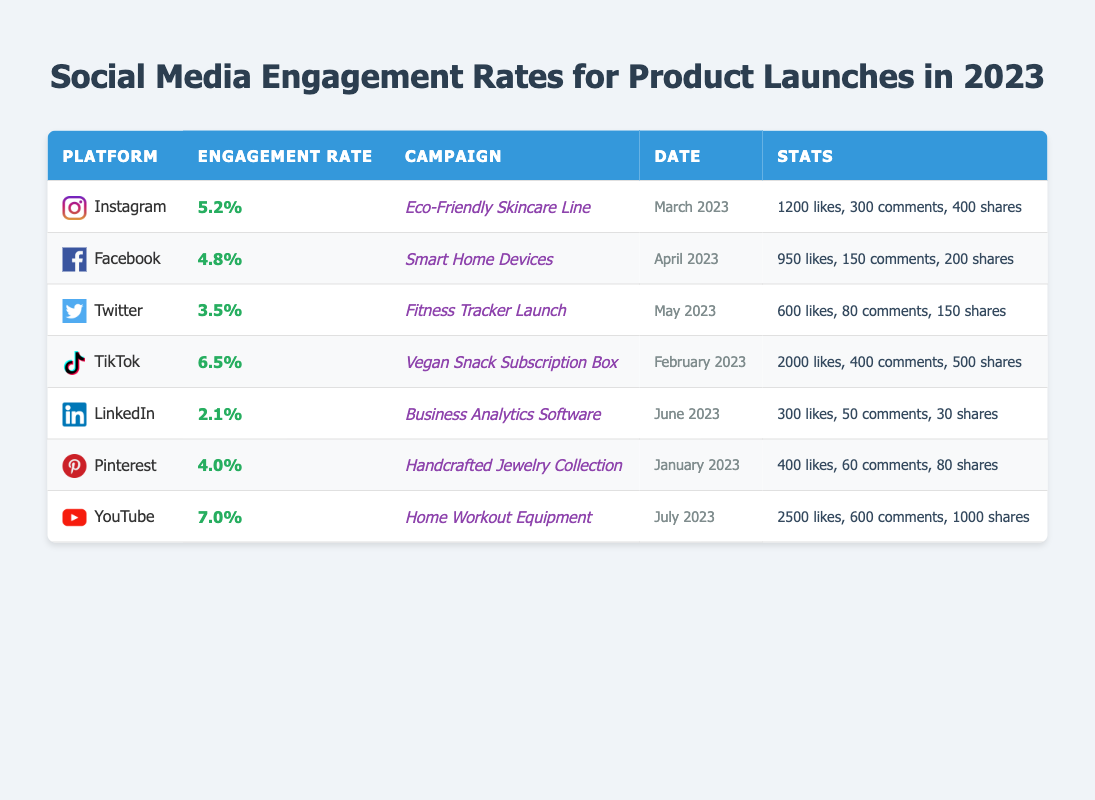What platform had the highest engagement rate for product launches? By reviewing the engagement rates listed in the table, TikTok has an engagement rate of 6.5%, which is the highest among all platforms.
Answer: TikTok What were the total likes for the Eco-Friendly Skincare Line campaign? The table indicates that the Eco-Friendly Skincare Line campaign on Instagram received 1200 likes.
Answer: 1200 likes Did the Home Workout Equipment campaign have more likes than the Vegan Snack Subscription Box campaign? The Home Workout Equipment campaign received 2500 likes, while the Vegan Snack Subscription Box received 2000 likes, so Home Workout Equipment had more likes.
Answer: Yes What is the average engagement rate for all campaigns listed in the table? The engagement rates are 5.2%, 4.8%, 3.5%, 6.5%, 2.1%, 4.0%, and 7.0%. Adding them gives a total of 33.1%. Dividing by the 7 campaigns yields an average engagement rate of approximately 4.73%.
Answer: 4.73% Which campaign had the lowest number of shares, and how many shares did it receive? By examining the shares column, the Business Analytics Software campaign on LinkedIn received only 30 shares, which is the lowest number of shares listed.
Answer: Business Analytics Software, 30 shares What is the difference in engagement rates between the highest and lowest performing campaigns? The highest engagement rate is from YouTube at 7.0%, and the lowest is LinkedIn at 2.1%. Subtracting gives 7.0% - 2.1% = 4.9%.
Answer: 4.9% How many comments did the Fitness Tracker Launch campaign receive? The table reveals that the Fitness Tracker Launch campaign garnered 80 comments.
Answer: 80 comments If we consider only Instagram and TikTok, which platform had a higher engagement rate and by how much? Instagram's engagement rate is 5.2% while TikTok's is 6.5%. The difference is calculated as 6.5% - 5.2% = 1.3%. TikTok had a higher engagement rate by 1.3%.
Answer: TikTok by 1.3% Which platform was used for the campaign "Smart Home Devices"? The Smart Home Devices campaign was conducted on Facebook, as listed in the table.
Answer: Facebook What proportions of the total interactions (likes, comments, shares) did the TikTok campaign receive compared to the total interactions of all campaigns? For TikTok, total interactions (likes + comments + shares) are 2000 + 400 + 500 = 2900. The total interactions across all campaigns are 1200 + 950 + 600 + 2000 + 300 + 400 + 2500 + 500 + 80 + 1000 = 11480. The proportion is 2900 / 11480 ≈ 0.2538 or 25.38%.
Answer: 25.38% 